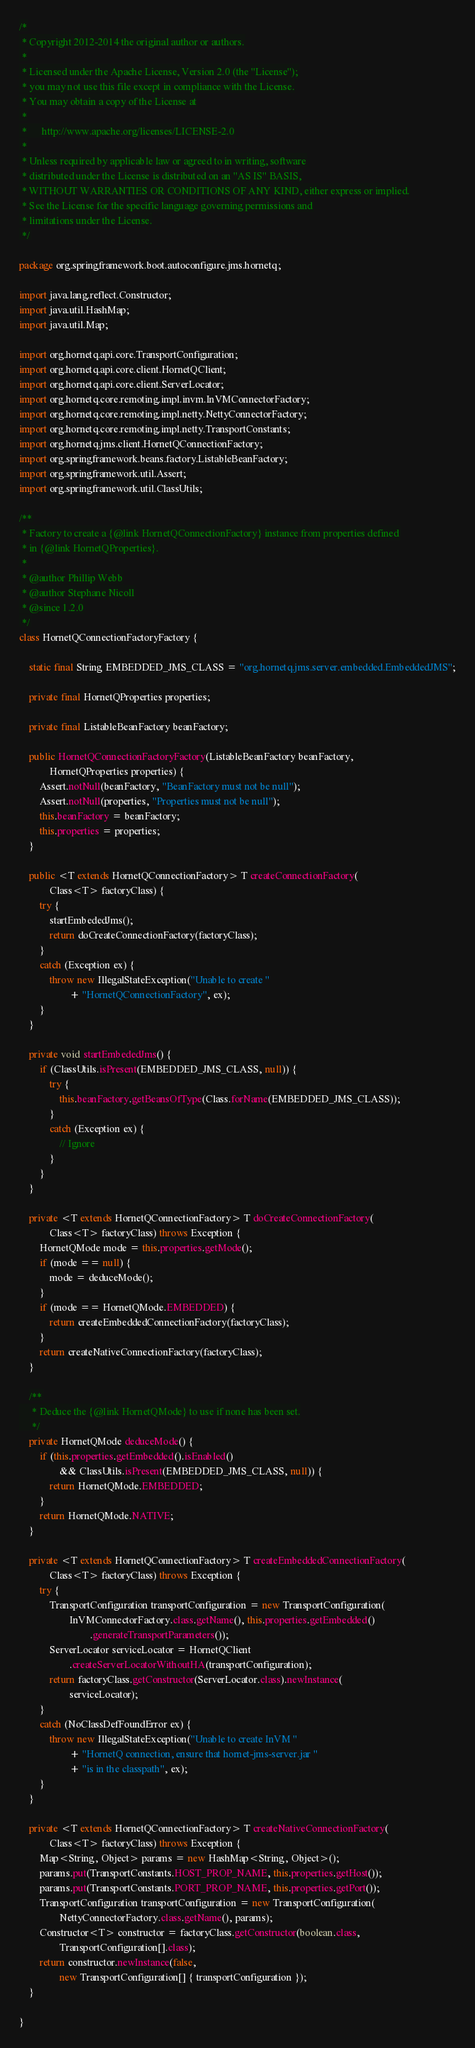<code> <loc_0><loc_0><loc_500><loc_500><_Java_>/*
 * Copyright 2012-2014 the original author or authors.
 *
 * Licensed under the Apache License, Version 2.0 (the "License");
 * you may not use this file except in compliance with the License.
 * You may obtain a copy of the License at
 *
 *      http://www.apache.org/licenses/LICENSE-2.0
 *
 * Unless required by applicable law or agreed to in writing, software
 * distributed under the License is distributed on an "AS IS" BASIS,
 * WITHOUT WARRANTIES OR CONDITIONS OF ANY KIND, either express or implied.
 * See the License for the specific language governing permissions and
 * limitations under the License.
 */

package org.springframework.boot.autoconfigure.jms.hornetq;

import java.lang.reflect.Constructor;
import java.util.HashMap;
import java.util.Map;

import org.hornetq.api.core.TransportConfiguration;
import org.hornetq.api.core.client.HornetQClient;
import org.hornetq.api.core.client.ServerLocator;
import org.hornetq.core.remoting.impl.invm.InVMConnectorFactory;
import org.hornetq.core.remoting.impl.netty.NettyConnectorFactory;
import org.hornetq.core.remoting.impl.netty.TransportConstants;
import org.hornetq.jms.client.HornetQConnectionFactory;
import org.springframework.beans.factory.ListableBeanFactory;
import org.springframework.util.Assert;
import org.springframework.util.ClassUtils;

/**
 * Factory to create a {@link HornetQConnectionFactory} instance from properties defined
 * in {@link HornetQProperties}.
 *
 * @author Phillip Webb
 * @author Stephane Nicoll
 * @since 1.2.0
 */
class HornetQConnectionFactoryFactory {

	static final String EMBEDDED_JMS_CLASS = "org.hornetq.jms.server.embedded.EmbeddedJMS";

	private final HornetQProperties properties;

	private final ListableBeanFactory beanFactory;

	public HornetQConnectionFactoryFactory(ListableBeanFactory beanFactory,
			HornetQProperties properties) {
		Assert.notNull(beanFactory, "BeanFactory must not be null");
		Assert.notNull(properties, "Properties must not be null");
		this.beanFactory = beanFactory;
		this.properties = properties;
	}

	public <T extends HornetQConnectionFactory> T createConnectionFactory(
			Class<T> factoryClass) {
		try {
			startEmbededJms();
			return doCreateConnectionFactory(factoryClass);
		}
		catch (Exception ex) {
			throw new IllegalStateException("Unable to create "
					+ "HornetQConnectionFactory", ex);
		}
	}

	private void startEmbededJms() {
		if (ClassUtils.isPresent(EMBEDDED_JMS_CLASS, null)) {
			try {
				this.beanFactory.getBeansOfType(Class.forName(EMBEDDED_JMS_CLASS));
			}
			catch (Exception ex) {
				// Ignore
			}
		}
	}

	private <T extends HornetQConnectionFactory> T doCreateConnectionFactory(
			Class<T> factoryClass) throws Exception {
		HornetQMode mode = this.properties.getMode();
		if (mode == null) {
			mode = deduceMode();
		}
		if (mode == HornetQMode.EMBEDDED) {
			return createEmbeddedConnectionFactory(factoryClass);
		}
		return createNativeConnectionFactory(factoryClass);
	}

	/**
	 * Deduce the {@link HornetQMode} to use if none has been set.
	 */
	private HornetQMode deduceMode() {
		if (this.properties.getEmbedded().isEnabled()
				&& ClassUtils.isPresent(EMBEDDED_JMS_CLASS, null)) {
			return HornetQMode.EMBEDDED;
		}
		return HornetQMode.NATIVE;
	}

	private <T extends HornetQConnectionFactory> T createEmbeddedConnectionFactory(
			Class<T> factoryClass) throws Exception {
		try {
			TransportConfiguration transportConfiguration = new TransportConfiguration(
					InVMConnectorFactory.class.getName(), this.properties.getEmbedded()
							.generateTransportParameters());
			ServerLocator serviceLocator = HornetQClient
					.createServerLocatorWithoutHA(transportConfiguration);
			return factoryClass.getConstructor(ServerLocator.class).newInstance(
					serviceLocator);
		}
		catch (NoClassDefFoundError ex) {
			throw new IllegalStateException("Unable to create InVM "
					+ "HornetQ connection, ensure that hornet-jms-server.jar "
					+ "is in the classpath", ex);
		}
	}

	private <T extends HornetQConnectionFactory> T createNativeConnectionFactory(
			Class<T> factoryClass) throws Exception {
		Map<String, Object> params = new HashMap<String, Object>();
		params.put(TransportConstants.HOST_PROP_NAME, this.properties.getHost());
		params.put(TransportConstants.PORT_PROP_NAME, this.properties.getPort());
		TransportConfiguration transportConfiguration = new TransportConfiguration(
				NettyConnectorFactory.class.getName(), params);
		Constructor<T> constructor = factoryClass.getConstructor(boolean.class,
				TransportConfiguration[].class);
		return constructor.newInstance(false,
				new TransportConfiguration[] { transportConfiguration });
	}

}
</code> 